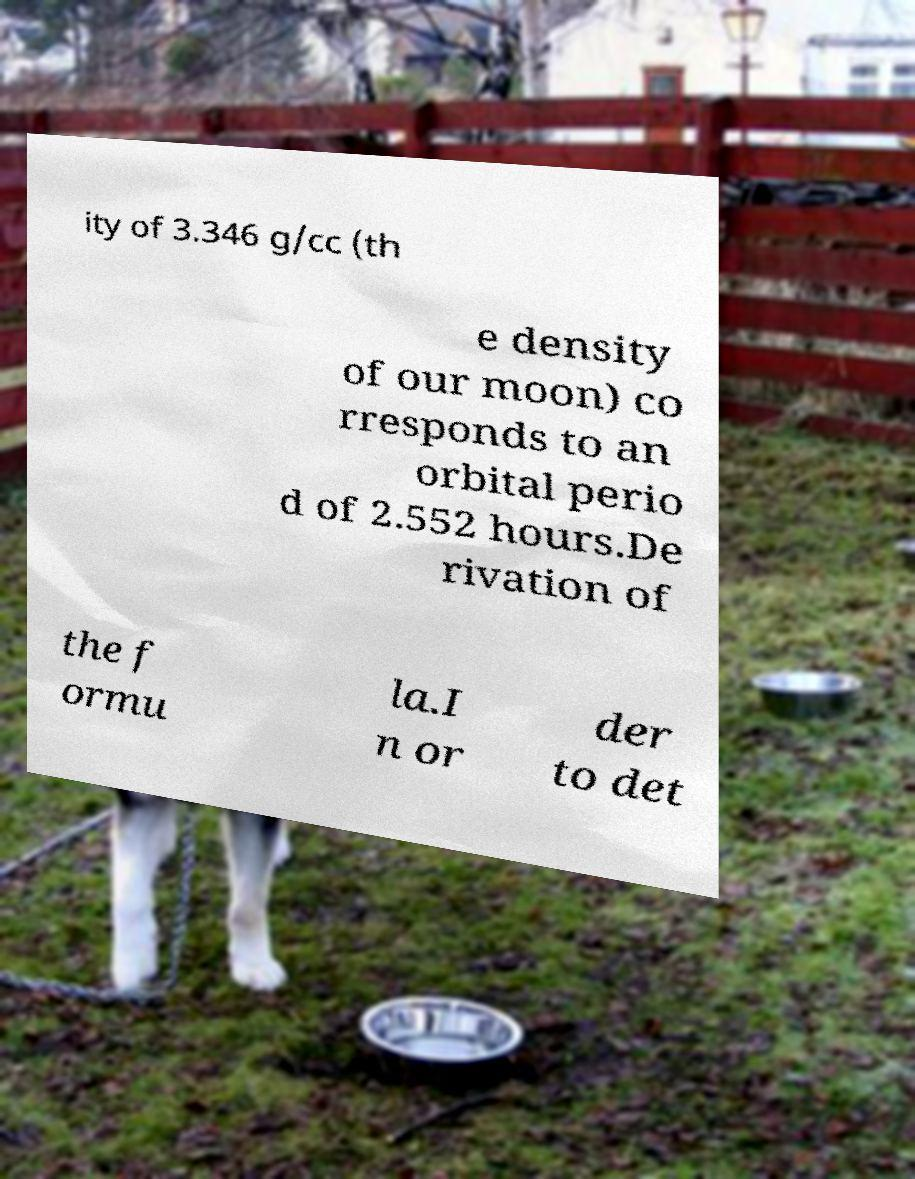Can you read and provide the text displayed in the image?This photo seems to have some interesting text. Can you extract and type it out for me? ity of 3.346 g/cc (th e density of our moon) co rresponds to an orbital perio d of 2.552 hours.De rivation of the f ormu la.I n or der to det 